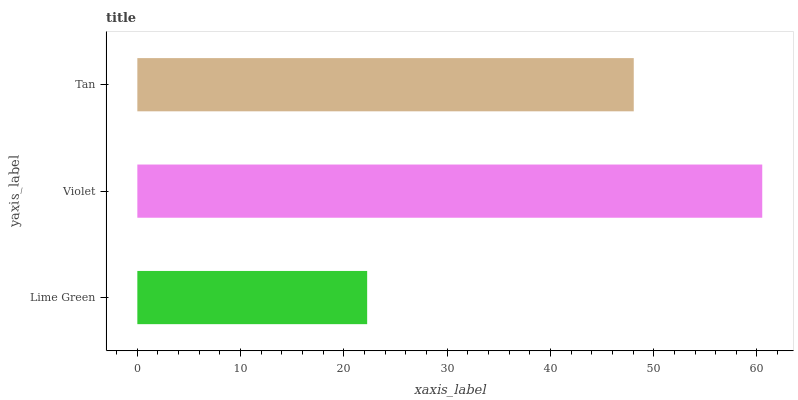Is Lime Green the minimum?
Answer yes or no. Yes. Is Violet the maximum?
Answer yes or no. Yes. Is Tan the minimum?
Answer yes or no. No. Is Tan the maximum?
Answer yes or no. No. Is Violet greater than Tan?
Answer yes or no. Yes. Is Tan less than Violet?
Answer yes or no. Yes. Is Tan greater than Violet?
Answer yes or no. No. Is Violet less than Tan?
Answer yes or no. No. Is Tan the high median?
Answer yes or no. Yes. Is Tan the low median?
Answer yes or no. Yes. Is Violet the high median?
Answer yes or no. No. Is Lime Green the low median?
Answer yes or no. No. 